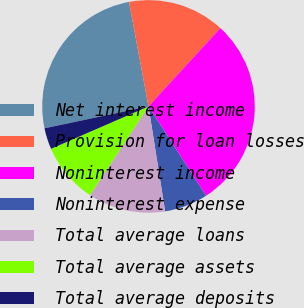Convert chart. <chart><loc_0><loc_0><loc_500><loc_500><pie_chart><fcel>Net interest income<fcel>Provision for loan losses<fcel>Noninterest income<fcel>Noninterest expense<fcel>Total average loans<fcel>Total average assets<fcel>Total average deposits<nl><fcel>25.37%<fcel>14.76%<fcel>29.06%<fcel>6.61%<fcel>11.78%<fcel>9.19%<fcel>3.23%<nl></chart> 